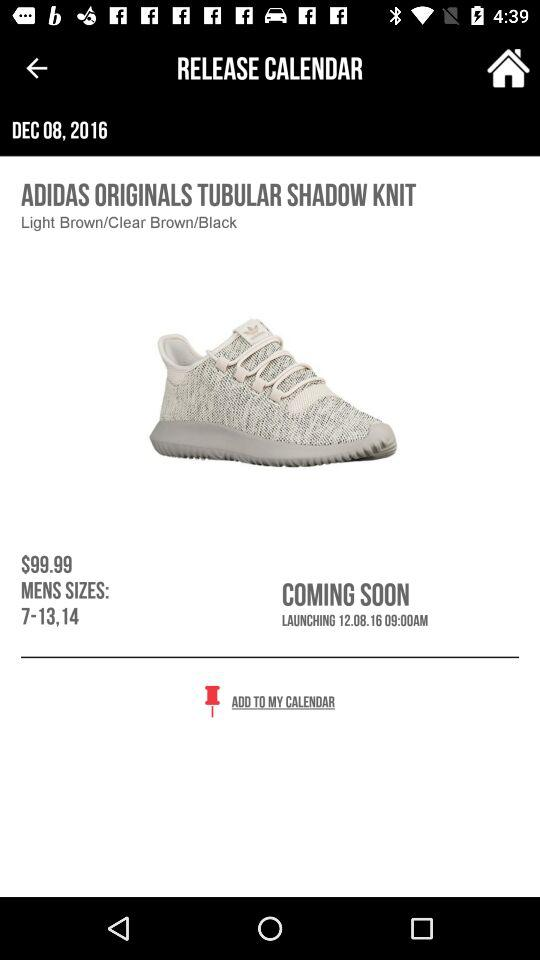What is the price of the Adidas Originals Tubular Shadow Knit?
Answer the question using a single word or phrase. $99.99 